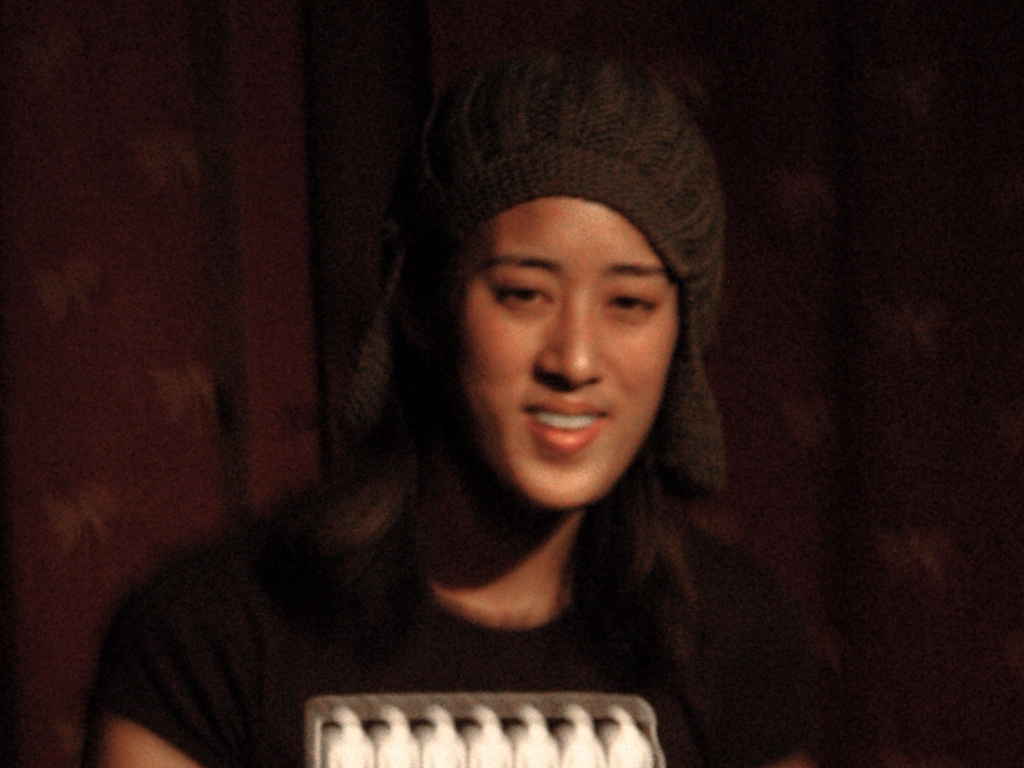Can you describe the setting or atmosphere in this image? The image appears to depict an indoor setting with dim, warm lighting, likely creating a cozy and intimate atmosphere. The background is not clearly visible due to the blurriness of the photo, but the darkness suggests it could be a nighttime setting or an indoor event with low ambient light. 